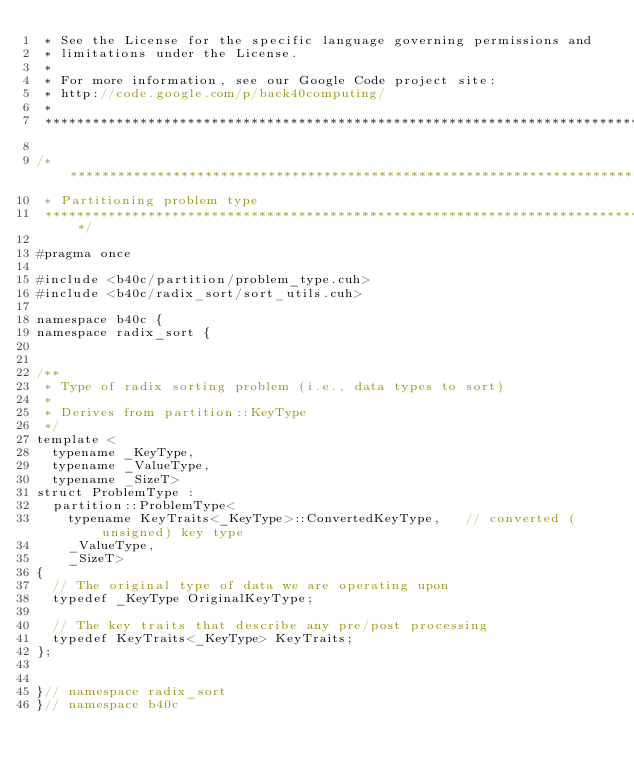Convert code to text. <code><loc_0><loc_0><loc_500><loc_500><_Cuda_> * See the License for the specific language governing permissions and
 * limitations under the License. 
 * 
 * For more information, see our Google Code project site: 
 * http://code.google.com/p/back40computing/
 * 
 ******************************************************************************/

/******************************************************************************
 * Partitioning problem type
 ******************************************************************************/

#pragma once

#include <b40c/partition/problem_type.cuh>
#include <b40c/radix_sort/sort_utils.cuh>

namespace b40c {
namespace radix_sort {


/**
 * Type of radix sorting problem (i.e., data types to sort)
 *
 * Derives from partition::KeyType
 */
template <
	typename _KeyType,
	typename _ValueType,
	typename _SizeT>
struct ProblemType :
	partition::ProblemType<
		typename KeyTraits<_KeyType>::ConvertedKeyType,		// converted (unsigned) key type
		_ValueType,
		_SizeT>
{
	// The original type of data we are operating upon
	typedef _KeyType OriginalKeyType;

	// The key traits that describe any pre/post processing
	typedef KeyTraits<_KeyType> KeyTraits;
};
		

}// namespace radix_sort
}// namespace b40c

</code> 